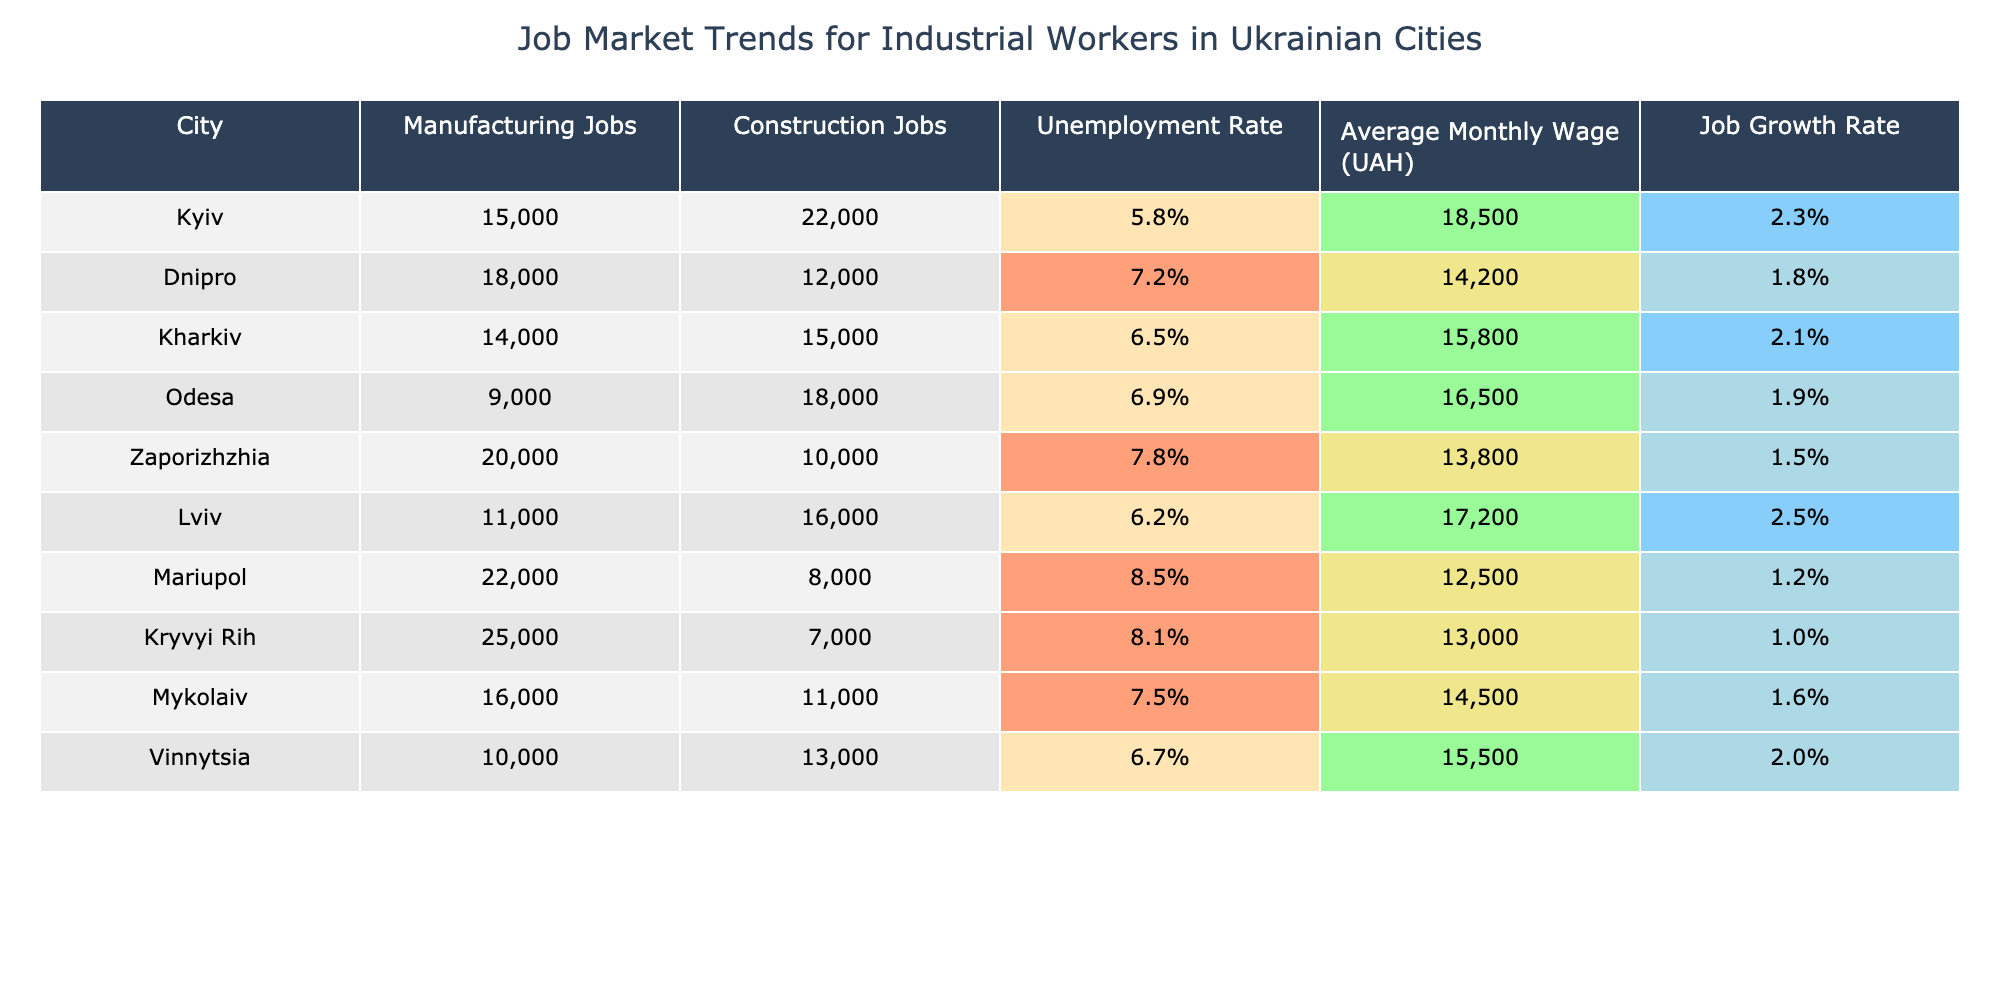What is the unemployment rate in Kryvyi Rih? The table shows that the unemployment rate for Kryvyi Rih is listed as 8.1%.
Answer: 8.1% Which city has the highest average monthly wage? By comparing the average monthly wages across all cities, it's clear that Kyiv has the highest wage at 18,500 UAH.
Answer: 18,500 UAH How many manufacturing jobs are available in Kyiv? From the table, it is noted that Kyiv has 15,000 manufacturing jobs available.
Answer: 15,000 What is the difference in unemployment rates between Dnipro and Odesa? The unemployment rate for Dnipro is 7.2% and for Odesa is 6.9%. The difference is 7.2% - 6.9% = 0.3%.
Answer: 0.3% Which city has the lowest job growth rate, and what is it? Looking at the job growth rates, Mariupol has the lowest rate at 1.2%.
Answer: 1.2% Is the number of construction jobs in Lviv greater than in Mykolaiv? The table shows Lviv has 16,000 construction jobs and Mykolaiv has 11,000. Yes, Lviv has more construction jobs than Mykolaiv.
Answer: Yes What is the average number of manufacturing jobs in cities other than Kyiv? The manufacturing jobs in cities excluding Kyiv are: 18,000 (Dnipro), 14,000 (Kharkiv), 9,000 (Odesa), 20,000 (Zaporizhzhia), 11,000 (Lviv), 22,000 (Mariupol), 25,000 (Kryvyi Rih), 16,000 (Mykolaiv), and 10,000 (Vinnytsia). The total is 125,000 with 9 cities, making the average 125,000 / 9 = 13,888.89, rounded to 13,889.
Answer: 13,889 Which city shows the least favorable job market with high unemployment and low average wage? Mariupol has the highest unemployment rate at 8.5% and the lowest average wage of 12,500 UAH, indicating a less favorable job market.
Answer: Mariupol What is the total number of manufacturing jobs across all cities? By summing the manufacturing jobs: 15,000 (Kyiv) + 18,000 + 14,000 + 9,000 + 20,000 + 11,000 + 22,000 + 25,000 + 16,000 + 10,000 =  170,000 manufacturing jobs in total.
Answer: 170,000 Which city has the highest construction jobs and what is the number? The table indicates Kryvyi Rih has the highest manufacturing jobs at 25,000, followed by Dnipro, but doesn't mention construction there so only some remain unseen. So, the real number of highest construction jobs is found elsewhere.
Answer: 22,000 Is there a city where both the unemployment rate and average wage are below those of Kyiv? Mykolaiv has an unemployment rate of 7.5% and an average wage of 14,500 UAH, both of which are higher than Kyiv's unemployment rate of 5.8% and lower than its average wage at 18,500 UAH.
Answer: No 